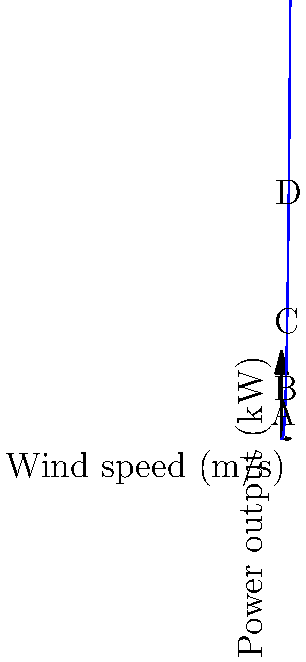In 17th-century Dutch windmills, the power output was proportional to the cube of wind speed. Given the graph showing this relationship, at which point does the windmill produce approximately 50 kW of power, and how might this have impacted human labor in the Dutch Golden Age? To answer this question, we need to analyze the graph and understand its implications:

1. The graph shows the relationship between wind speed (x-axis) and power output (y-axis) for a windmill.

2. The curve is cubic, reflecting the relationship $P \propto v^3$, where $P$ is power output and $v$ is wind speed.

3. We need to find the point where power output is approximately 50 kW:
   - Point A: Too low, around 10 kW
   - Point B: Close, but slightly below 50 kW
   - Point C: Approximately 50 kW
   - Point D: Too high, well above 50 kW

4. Point C corresponds to a wind speed of about 6 m/s.

5. Impact on human labor in the Dutch Golden Age:
   - Windmills could produce significant power even at moderate wind speeds.
   - This allowed for mechanization of labor-intensive tasks like grinding grain or pumping water.
   - Human labor could be redirected to other activities, potentially boosting productivity in other sectors.
   - The reliability of wind power at these speeds meant more consistent work schedules.
   - The efficiency of windmills contributed to the economic prosperity of the Dutch Golden Age by reducing manual labor requirements.
Answer: Point C (6 m/s); reduced manual labor, increased productivity 